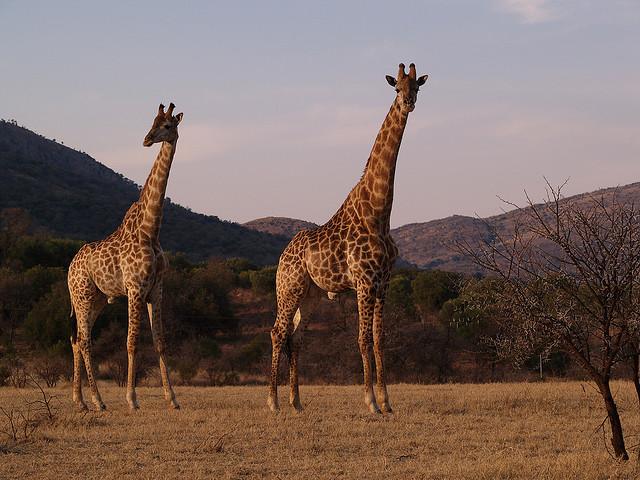What is in the back of the giraffes?
Short answer required. Mountains. How many animals are there?
Write a very short answer. 2. How many giraffes?
Write a very short answer. 2. Are the giraffes in their natural habitat?
Give a very brief answer. Yes. How many animals are in the image?
Quick response, please. 2. How many giraffe are standing in the field?
Keep it brief. 2. What is the one giraffe looking at off to the side?
Answer briefly. Yes. Are they both male?
Answer briefly. Yes. How many giraffes are there?
Short answer required. 2. Are the giraffe's contained?
Write a very short answer. No. Is this animals standing or walking around?
Be succinct. Standing. Which direction are they headed?
Give a very brief answer. Right. Are both of these giraffes mature?
Keep it brief. Yes. Is this an older or young giraffe?
Quick response, please. Older. 